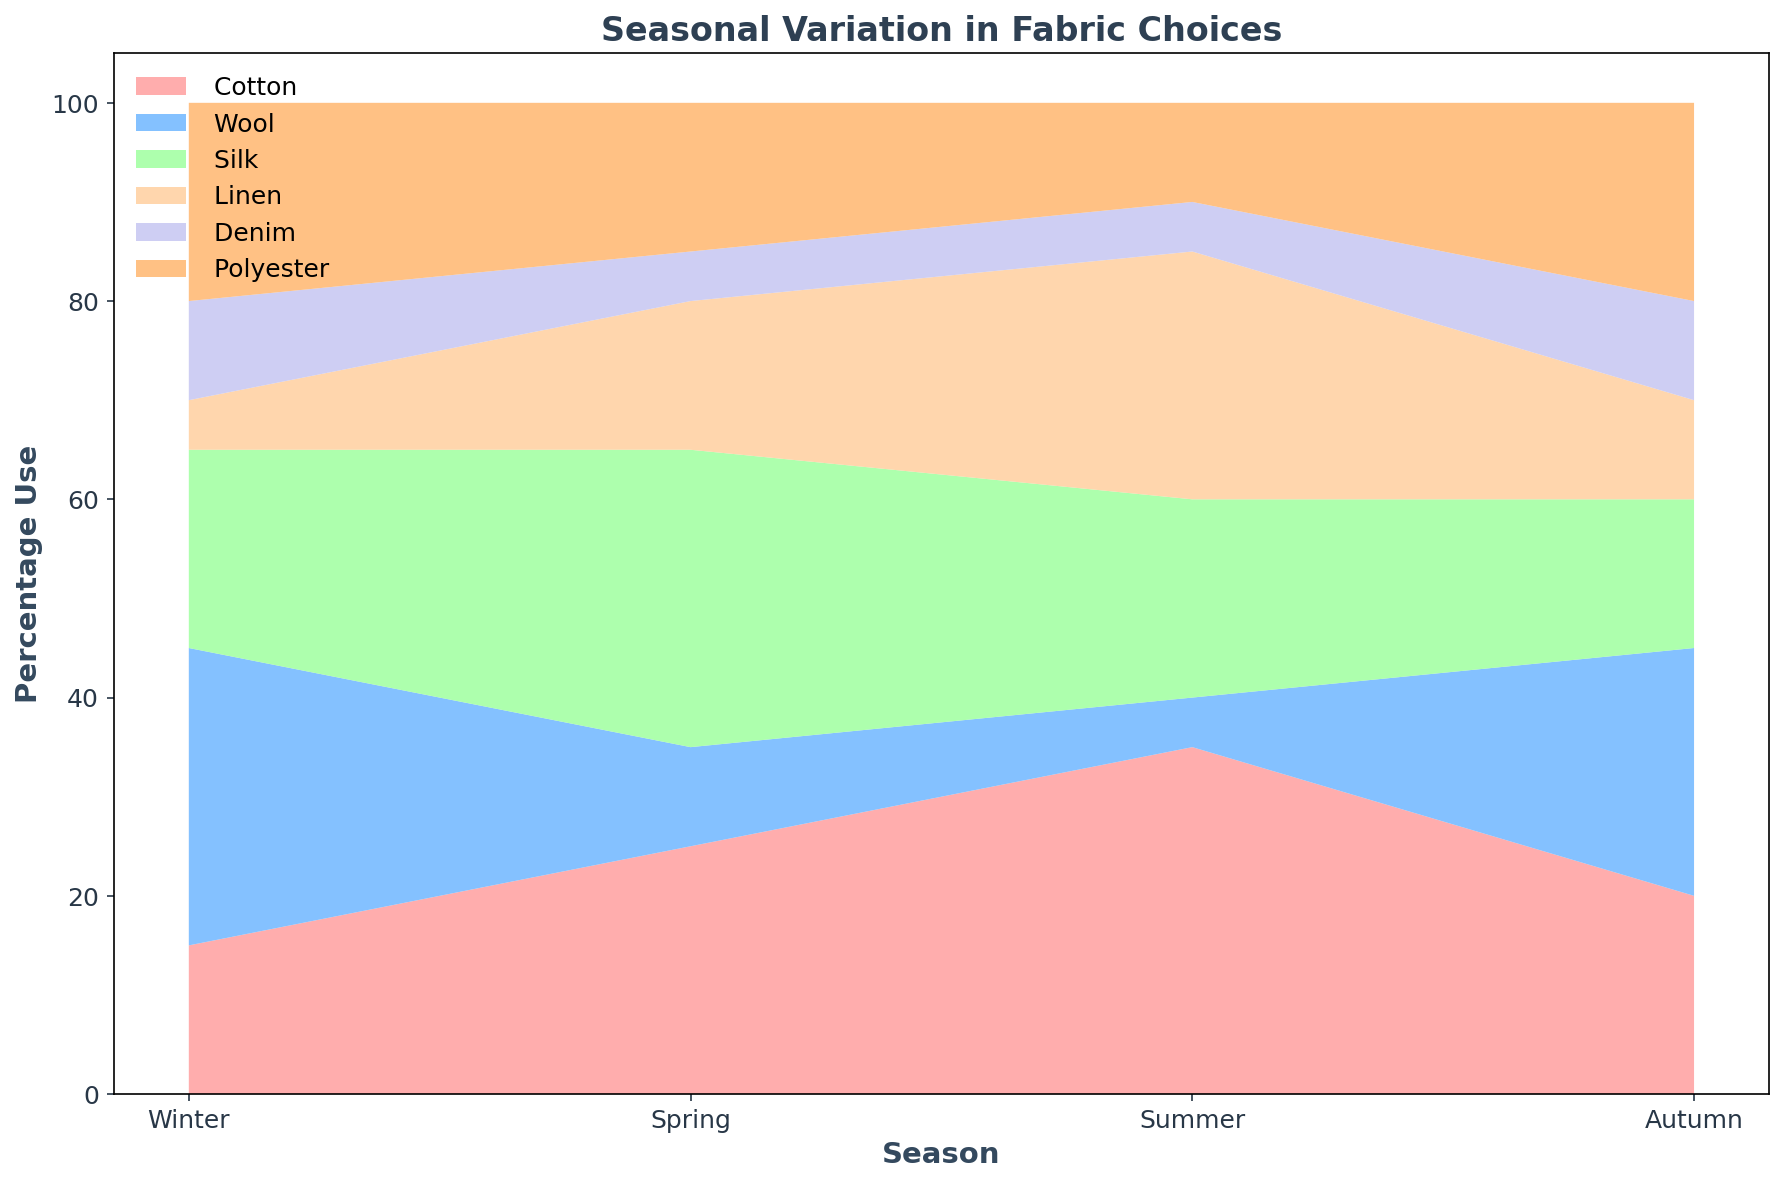What season has the highest usage of Linen? In the area chart, we observe that the height of the Linen (yellow section) segment is tallest in the Summer season.
Answer: Summer During which season is Polyester usage the lowest? Observing the area chart, the height of the Polyester (orange section) area is lowest in the Summer season.
Answer: Summer Which fabric has the most stable usage across all seasons? Looking at the area chart and comparing the relative heights of each fabric segment, Denim (purple) seems to maintain a relatively consistent usage throughout the seasons.
Answer: Denim What is the total usage of Cotton and Silk in Spring? In the Spring season, Cotton usage is 25%, and Silk usage is 30%. Adding these together gives 25 + 30 = 55%.
Answer: 55% Compare the usage of Wool and Polyester in Winter. Which one is used more and by how much? In the Winter season, Wool usage is 30% and Polyester usage is 20%. Wool is used more by 30 - 20 = 10%.
Answer: Wool, 10% What is the average usage of Cotton across all seasons? The Cotton usage for each season is Winter: 15%, Spring: 25%, Summer: 35%, Autumn: 20%. The average is (15 + 25 + 35 + 20) / 4 = 95 / 4 = 23.75%.
Answer: 23.75% Which fabric experiences the most significant decrease in usage from Spring to Winter? Observing the area chart, Silk usage drops from 30% in Spring to 20% in Winter, a decrease of 10%. Other fabrics do not show a more significant drop.
Answer: Silk How does the usage of Wool in Autumn compare to that in Winter? In the Autumn season, Wool usage is 25%, while in the Winter, it is 30%. Wool usage in Winter is 5% more than in Autumn.
Answer: Winter has 5% more What is the total percentage of fabrics used in Autumn? In Autumn, the sum of usage percentages for Cotton (20%), Wool (25%), Silk (15%), Linen (10%), Denim (10%), and Polyester (20%) totals 20 + 25 + 15 + 10 + 10 + 20 = 100%.
Answer: 100% 